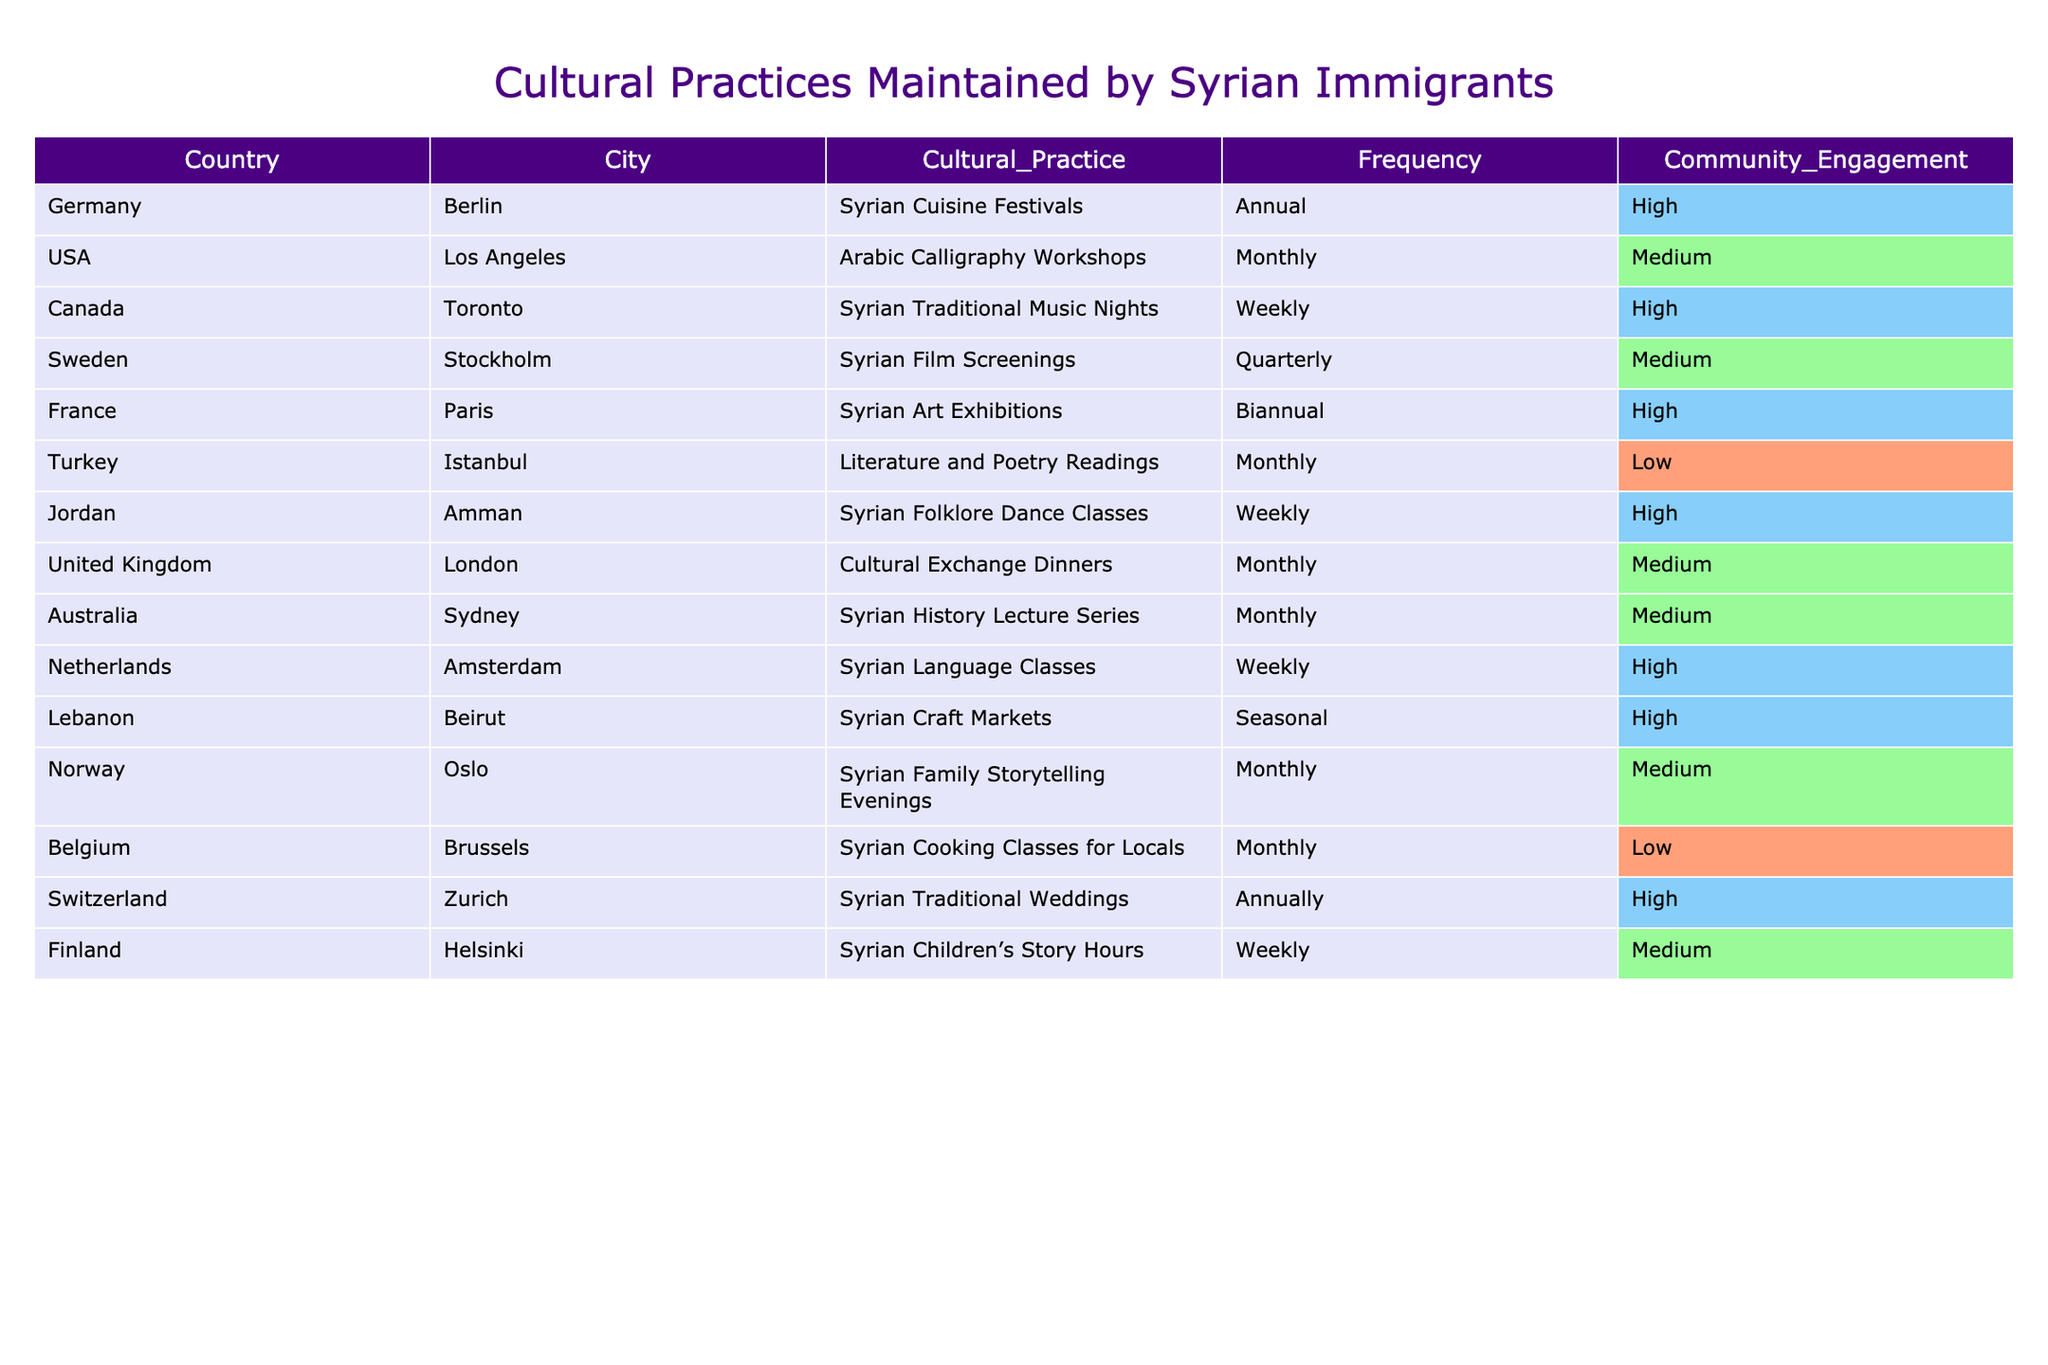What cultural practice is held annually in Berlin? According to the table, the cultural practice held annually in Berlin is the "Syrian Cuisine Festivals."
Answer: Syrian Cuisine Festivals How often are Syrian Traditional Music Nights held in Toronto? The table shows that the Syrian Traditional Music Nights in Toronto are held weekly.
Answer: Weekly In how many cities in the USA are cultural practices listed? The table indicates that there is one city in the USA listed, which is Los Angeles.
Answer: One Is there a community engagement for Syrian Language Classes in Amsterdam? Yes, the table states that the community engagement for Syrian Language Classes in Amsterdam is high.
Answer: Yes What is the difference in frequency between "Syrian Film Screenings" in Stockholm and "Syrian Craft Markets" in Beirut? "Syrian Film Screenings" in Stockholm occur quarterly, while "Syrian Craft Markets" in Beirut are seasonal. Since there is no numerical value assigned to seasonal, we can interpret quarterly as more frequent than seasonal.
Answer: Quarterly is more frequent than seasonal Which country has the lowest community engagement listed? The table shows that both Turkey (Istanbul) and Belgium (Brussels) have low community engagement.
Answer: Turkey and Belgium What percentage of the listed practices involve high community engagement? There are 8 practices in total, and 5 of them have high community engagement (Berlin, Toronto, Paris, Beirut, Zurich). Thus, (5/12) * 100 = 41.67%.
Answer: 41.67% In how many countries is a cultural practice held monthly? The cities with monthly cultural practices are Los Angeles, Istanbul, London, Sydney, and Oslo. This totals to 5 countries with monthly practices.
Answer: 5 countries What is the frequency of community engagement for the "Literature and Poetry Readings" in Istanbul? The table specifies that the "Literature and Poetry Readings" in Istanbul have low community engagement.
Answer: Low Which city hosts a cultural practice that is both seasonal and involves high community engagement? The table indicates that Beirut hosts the "Syrian Craft Markets," which are seasonal and have high community engagement.
Answer: Beirut Are there more cultural practices held weekly or monthly according to the table? By counting, there are 6 monthly practices (Los Angeles, Istanbul, London, Sydney, Oslo, and Brussels) and 5 weekly practices (Toronto, Amman, Amsterdam, Helsinki). Therefore, there are more monthly practices.
Answer: Monthly practices are more 